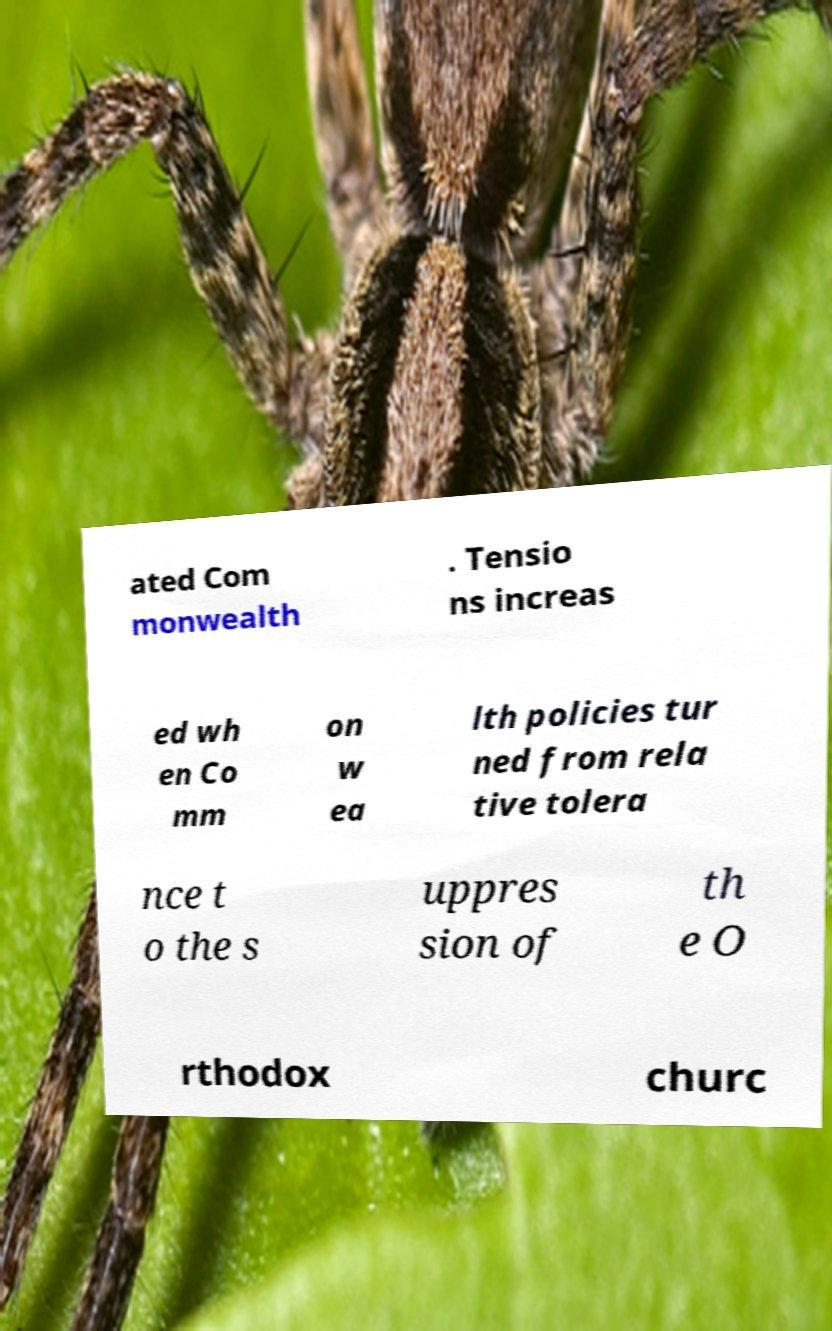Please identify and transcribe the text found in this image. ated Com monwealth . Tensio ns increas ed wh en Co mm on w ea lth policies tur ned from rela tive tolera nce t o the s uppres sion of th e O rthodox churc 